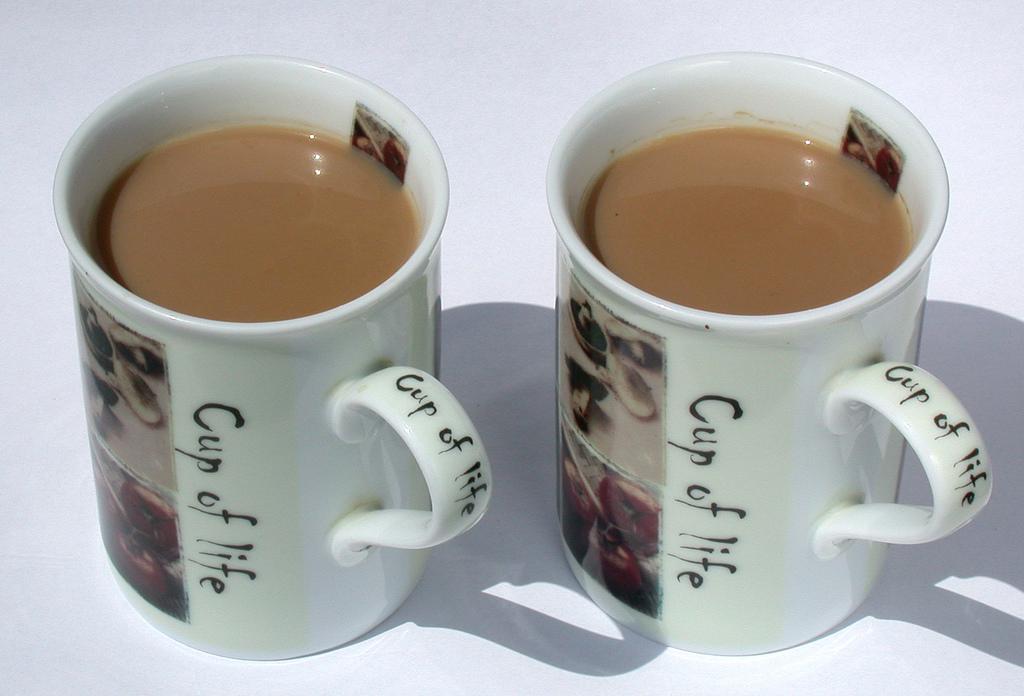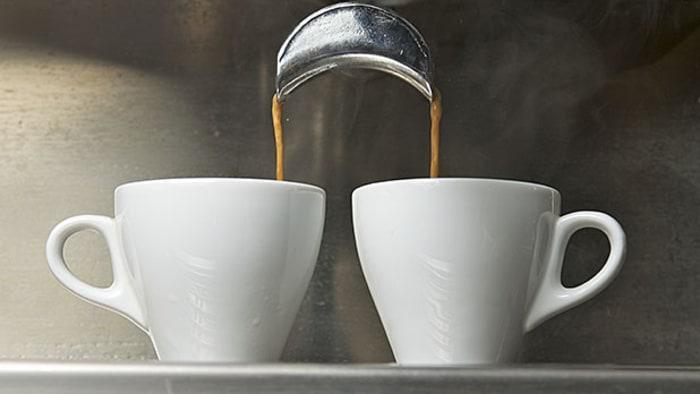The first image is the image on the left, the second image is the image on the right. For the images shown, is this caption "Several coffee beans are near a white cup of steaming beverage on a white saucer." true? Answer yes or no. No. The first image is the image on the left, the second image is the image on the right. Assess this claim about the two images: "All of the mugs are sitting on saucers.". Correct or not? Answer yes or no. No. 